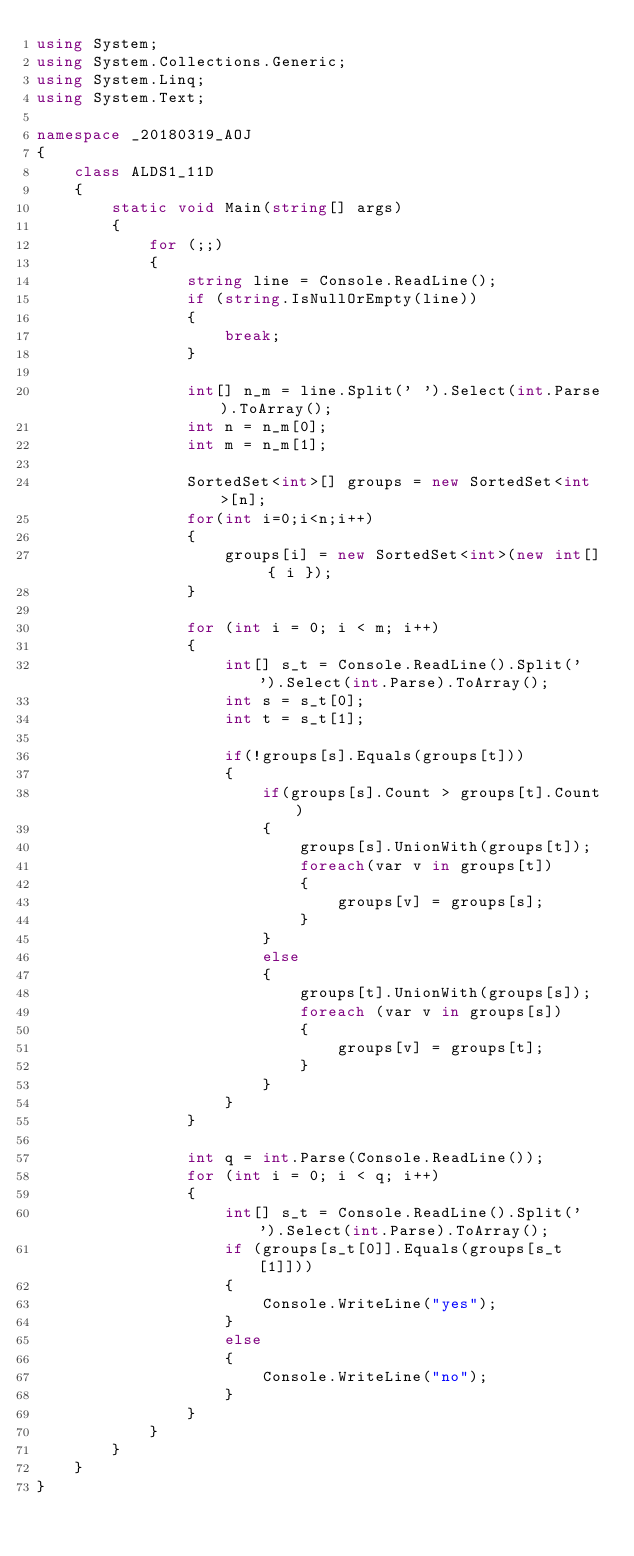<code> <loc_0><loc_0><loc_500><loc_500><_C#_>using System;
using System.Collections.Generic;
using System.Linq;
using System.Text;

namespace _20180319_AOJ
{
    class ALDS1_11D
    {
        static void Main(string[] args)
        {
            for (;;)
            {
                string line = Console.ReadLine();
                if (string.IsNullOrEmpty(line))
                {
                    break;
                }

                int[] n_m = line.Split(' ').Select(int.Parse).ToArray();
                int n = n_m[0];
                int m = n_m[1];

                SortedSet<int>[] groups = new SortedSet<int>[n];
                for(int i=0;i<n;i++)
                {
                    groups[i] = new SortedSet<int>(new int[] { i });
                }

                for (int i = 0; i < m; i++)
                {
                    int[] s_t = Console.ReadLine().Split(' ').Select(int.Parse).ToArray();
                    int s = s_t[0];
                    int t = s_t[1];
                    
                    if(!groups[s].Equals(groups[t]))
                    {
                        if(groups[s].Count > groups[t].Count)
                        {
                            groups[s].UnionWith(groups[t]);
                            foreach(var v in groups[t])
                            {
                                groups[v] = groups[s];
                            }
                        }
                        else
                        {
                            groups[t].UnionWith(groups[s]);
                            foreach (var v in groups[s])
                            {
                                groups[v] = groups[t];
                            }
                        }
                    }
                }

                int q = int.Parse(Console.ReadLine());
                for (int i = 0; i < q; i++)
                {
                    int[] s_t = Console.ReadLine().Split(' ').Select(int.Parse).ToArray();
                    if (groups[s_t[0]].Equals(groups[s_t[1]]))
                    {
                        Console.WriteLine("yes");
                    }
                    else
                    {
                        Console.WriteLine("no");
                    }
                }
            }
        }
    }
}

</code> 